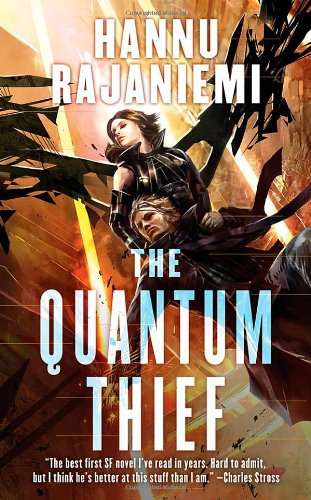Is this a sci-fi book? Yes, this book is a prime example of the sci-fi genre, using advanced scientific concepts and future-oriented narratives to craft its engaging plot. 